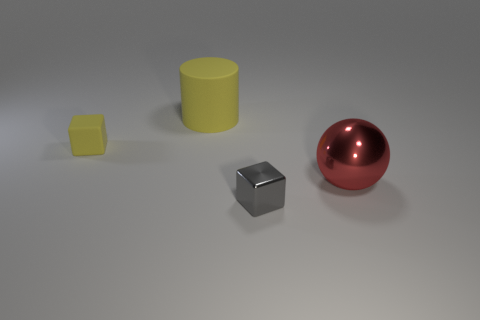Add 4 brown metallic cylinders. How many objects exist? 8 Subtract all balls. How many objects are left? 3 Subtract 0 brown spheres. How many objects are left? 4 Subtract all yellow cylinders. Subtract all yellow rubber cylinders. How many objects are left? 2 Add 1 spheres. How many spheres are left? 2 Add 2 big purple objects. How many big purple objects exist? 2 